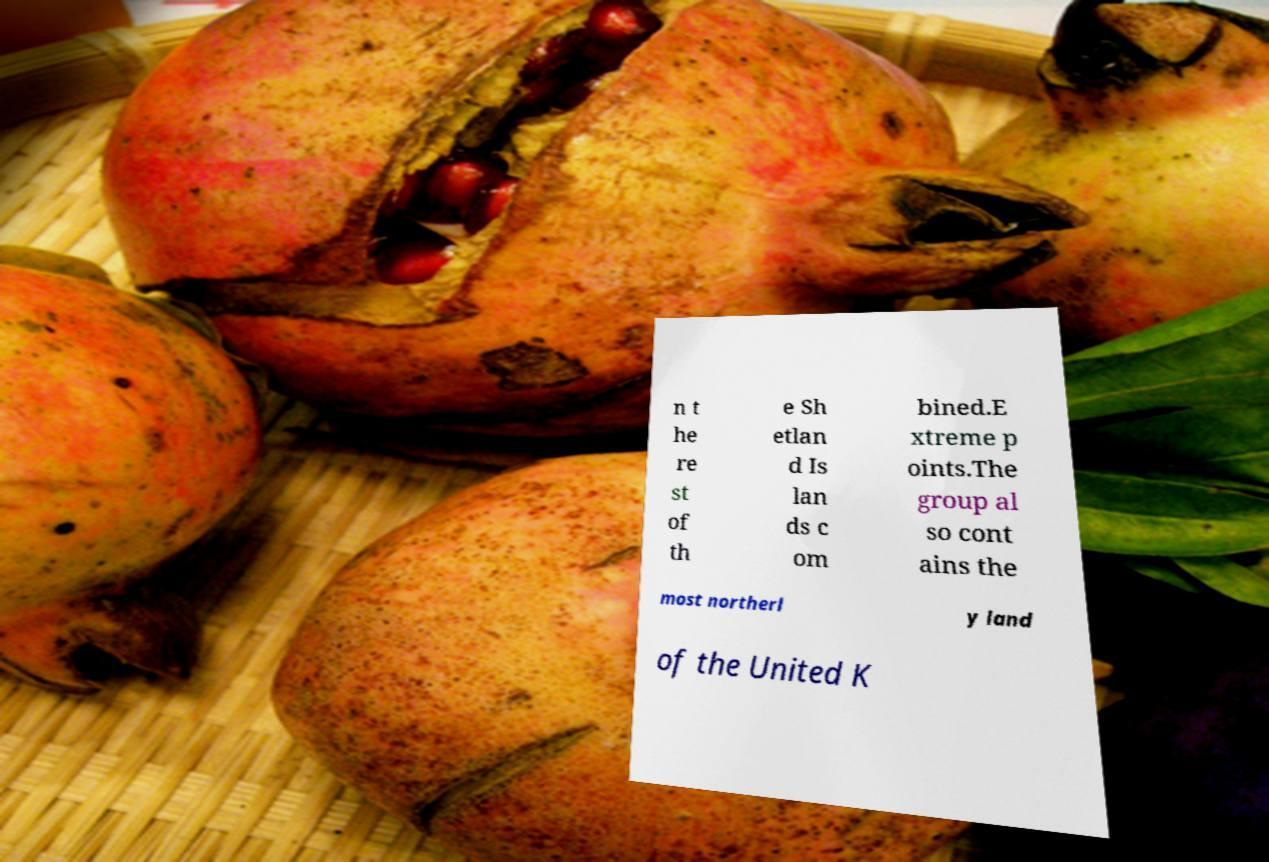Could you assist in decoding the text presented in this image and type it out clearly? n t he re st of th e Sh etlan d Is lan ds c om bined.E xtreme p oints.The group al so cont ains the most northerl y land of the United K 